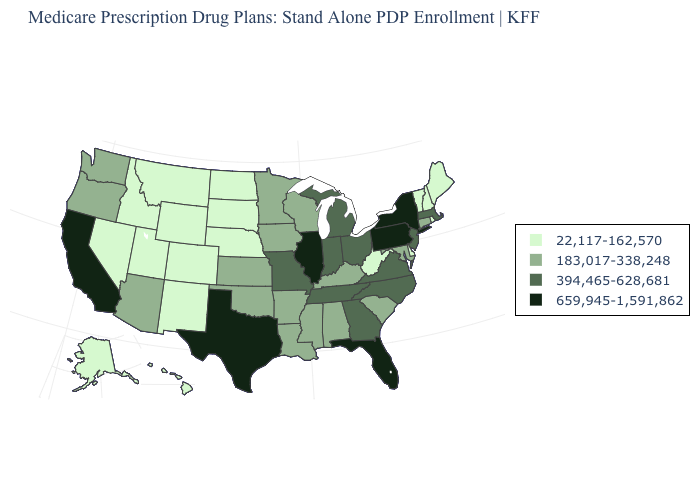What is the value of Texas?
Quick response, please. 659,945-1,591,862. Is the legend a continuous bar?
Short answer required. No. What is the value of West Virginia?
Write a very short answer. 22,117-162,570. Name the states that have a value in the range 659,945-1,591,862?
Answer briefly. California, Florida, Illinois, New York, Pennsylvania, Texas. What is the lowest value in states that border Mississippi?
Quick response, please. 183,017-338,248. What is the value of Pennsylvania?
Give a very brief answer. 659,945-1,591,862. What is the highest value in the MidWest ?
Keep it brief. 659,945-1,591,862. Name the states that have a value in the range 659,945-1,591,862?
Quick response, please. California, Florida, Illinois, New York, Pennsylvania, Texas. Name the states that have a value in the range 394,465-628,681?
Give a very brief answer. Georgia, Indiana, Massachusetts, Michigan, Missouri, North Carolina, New Jersey, Ohio, Tennessee, Virginia. What is the lowest value in the Northeast?
Short answer required. 22,117-162,570. What is the lowest value in states that border California?
Keep it brief. 22,117-162,570. Among the states that border Arkansas , does Mississippi have the lowest value?
Give a very brief answer. Yes. Among the states that border California , does Arizona have the highest value?
Be succinct. Yes. What is the lowest value in the USA?
Be succinct. 22,117-162,570. Name the states that have a value in the range 22,117-162,570?
Short answer required. Alaska, Colorado, Delaware, Hawaii, Idaho, Maine, Montana, North Dakota, Nebraska, New Hampshire, New Mexico, Nevada, Rhode Island, South Dakota, Utah, Vermont, West Virginia, Wyoming. 